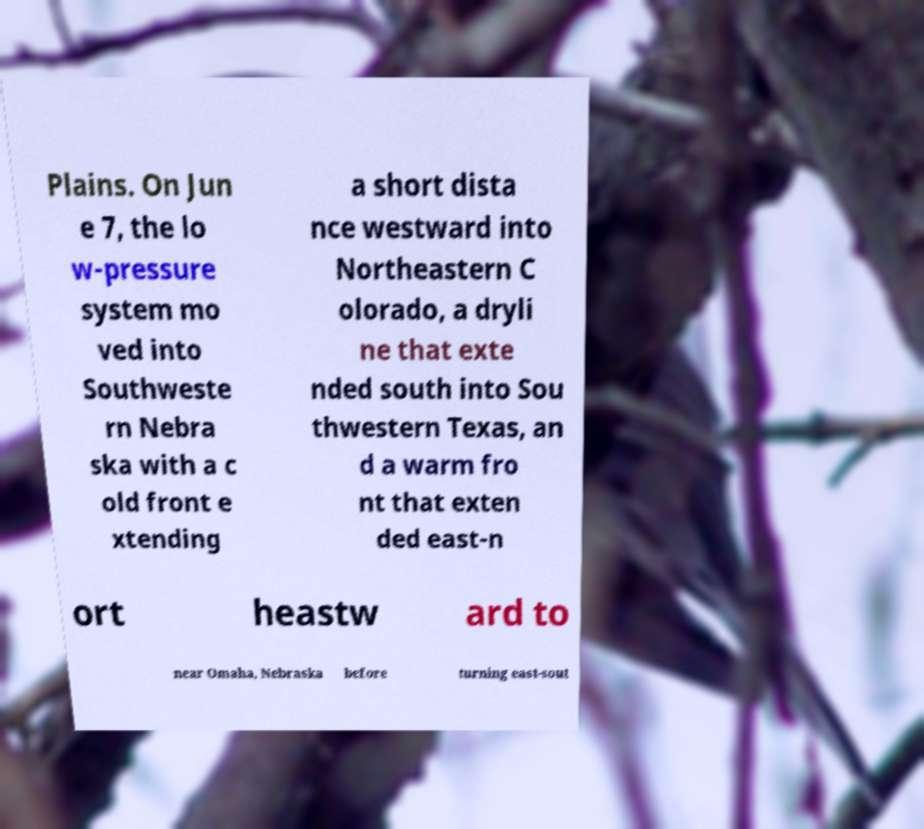Could you assist in decoding the text presented in this image and type it out clearly? Plains. On Jun e 7, the lo w-pressure system mo ved into Southweste rn Nebra ska with a c old front e xtending a short dista nce westward into Northeastern C olorado, a dryli ne that exte nded south into Sou thwestern Texas, an d a warm fro nt that exten ded east-n ort heastw ard to near Omaha, Nebraska before turning east-sout 